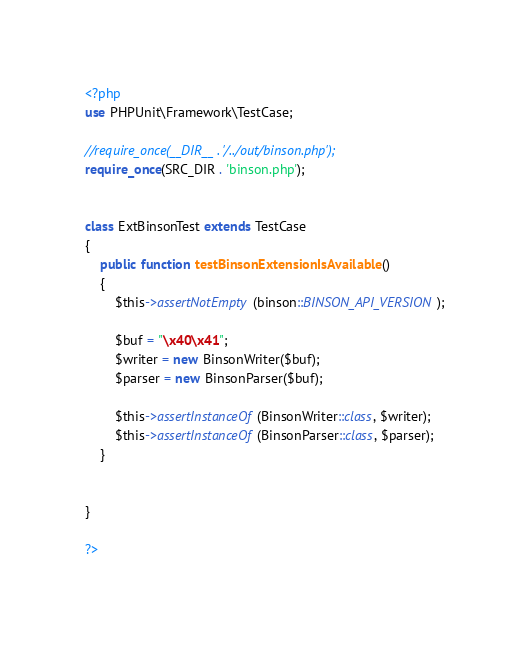Convert code to text. <code><loc_0><loc_0><loc_500><loc_500><_PHP_><?php
use PHPUnit\Framework\TestCase;

//require_once(__DIR__ . '/../out/binson.php');
require_once(SRC_DIR . 'binson.php');


class ExtBinsonTest extends TestCase
{
    public function testBinsonExtensionIsAvailable()
    {   
		$this->assertNotEmpty(binson::BINSON_API_VERSION);

        $buf = "\x40\x41";
        $writer = new BinsonWriter($buf);
        $parser = new BinsonParser($buf);

        $this->assertInstanceOf(BinsonWriter::class, $writer);
        $this->assertInstanceOf(BinsonParser::class, $parser);
    }
    

}

?></code> 